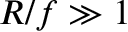<formula> <loc_0><loc_0><loc_500><loc_500>R / f \gg 1</formula> 